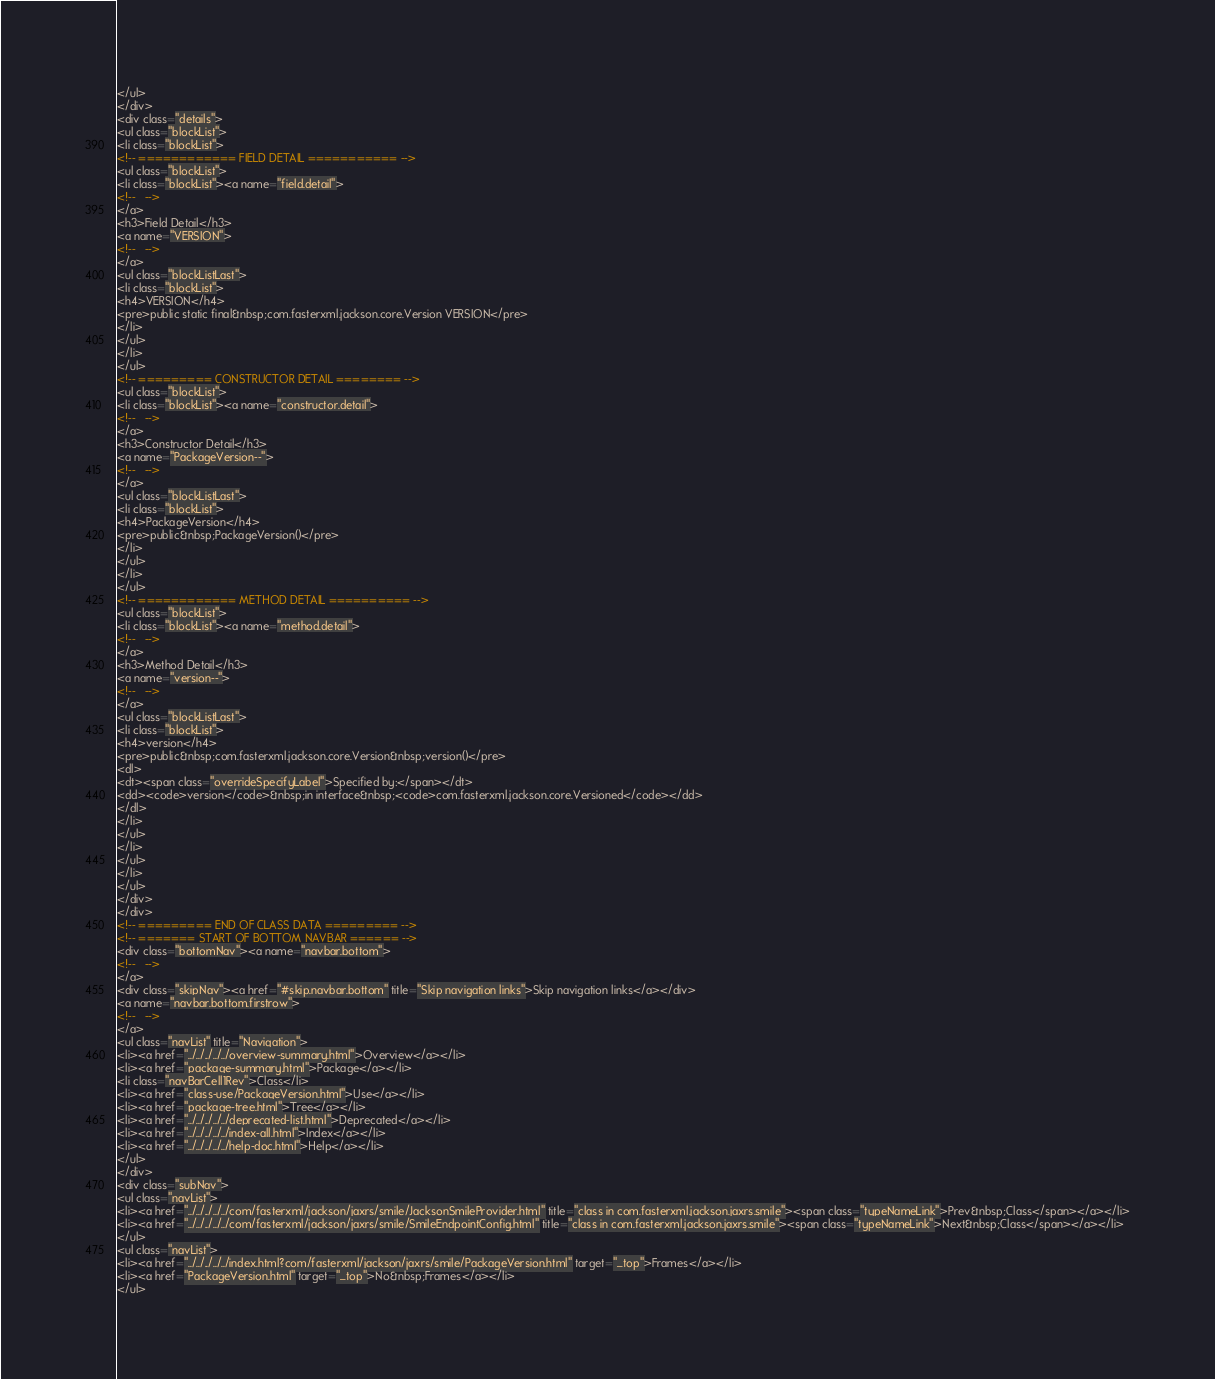Convert code to text. <code><loc_0><loc_0><loc_500><loc_500><_HTML_></ul>
</div>
<div class="details">
<ul class="blockList">
<li class="blockList">
<!-- ============ FIELD DETAIL =========== -->
<ul class="blockList">
<li class="blockList"><a name="field.detail">
<!--   -->
</a>
<h3>Field Detail</h3>
<a name="VERSION">
<!--   -->
</a>
<ul class="blockListLast">
<li class="blockList">
<h4>VERSION</h4>
<pre>public static final&nbsp;com.fasterxml.jackson.core.Version VERSION</pre>
</li>
</ul>
</li>
</ul>
<!-- ========= CONSTRUCTOR DETAIL ======== -->
<ul class="blockList">
<li class="blockList"><a name="constructor.detail">
<!--   -->
</a>
<h3>Constructor Detail</h3>
<a name="PackageVersion--">
<!--   -->
</a>
<ul class="blockListLast">
<li class="blockList">
<h4>PackageVersion</h4>
<pre>public&nbsp;PackageVersion()</pre>
</li>
</ul>
</li>
</ul>
<!-- ============ METHOD DETAIL ========== -->
<ul class="blockList">
<li class="blockList"><a name="method.detail">
<!--   -->
</a>
<h3>Method Detail</h3>
<a name="version--">
<!--   -->
</a>
<ul class="blockListLast">
<li class="blockList">
<h4>version</h4>
<pre>public&nbsp;com.fasterxml.jackson.core.Version&nbsp;version()</pre>
<dl>
<dt><span class="overrideSpecifyLabel">Specified by:</span></dt>
<dd><code>version</code>&nbsp;in interface&nbsp;<code>com.fasterxml.jackson.core.Versioned</code></dd>
</dl>
</li>
</ul>
</li>
</ul>
</li>
</ul>
</div>
</div>
<!-- ========= END OF CLASS DATA ========= -->
<!-- ======= START OF BOTTOM NAVBAR ====== -->
<div class="bottomNav"><a name="navbar.bottom">
<!--   -->
</a>
<div class="skipNav"><a href="#skip.navbar.bottom" title="Skip navigation links">Skip navigation links</a></div>
<a name="navbar.bottom.firstrow">
<!--   -->
</a>
<ul class="navList" title="Navigation">
<li><a href="../../../../../overview-summary.html">Overview</a></li>
<li><a href="package-summary.html">Package</a></li>
<li class="navBarCell1Rev">Class</li>
<li><a href="class-use/PackageVersion.html">Use</a></li>
<li><a href="package-tree.html">Tree</a></li>
<li><a href="../../../../../deprecated-list.html">Deprecated</a></li>
<li><a href="../../../../../index-all.html">Index</a></li>
<li><a href="../../../../../help-doc.html">Help</a></li>
</ul>
</div>
<div class="subNav">
<ul class="navList">
<li><a href="../../../../../com/fasterxml/jackson/jaxrs/smile/JacksonSmileProvider.html" title="class in com.fasterxml.jackson.jaxrs.smile"><span class="typeNameLink">Prev&nbsp;Class</span></a></li>
<li><a href="../../../../../com/fasterxml/jackson/jaxrs/smile/SmileEndpointConfig.html" title="class in com.fasterxml.jackson.jaxrs.smile"><span class="typeNameLink">Next&nbsp;Class</span></a></li>
</ul>
<ul class="navList">
<li><a href="../../../../../index.html?com/fasterxml/jackson/jaxrs/smile/PackageVersion.html" target="_top">Frames</a></li>
<li><a href="PackageVersion.html" target="_top">No&nbsp;Frames</a></li>
</ul></code> 